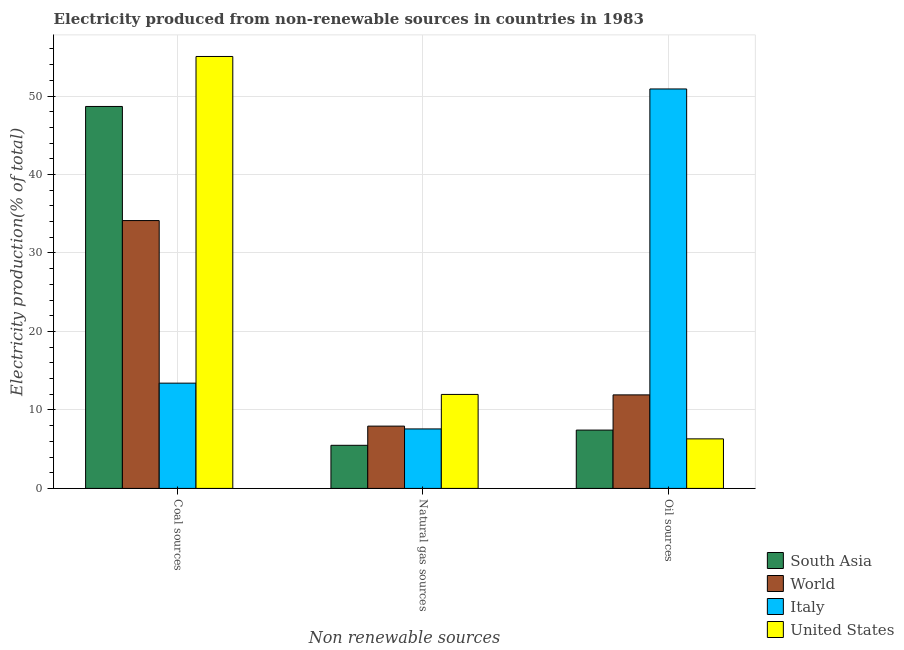How many groups of bars are there?
Offer a very short reply. 3. Are the number of bars per tick equal to the number of legend labels?
Your response must be concise. Yes. Are the number of bars on each tick of the X-axis equal?
Give a very brief answer. Yes. How many bars are there on the 2nd tick from the left?
Ensure brevity in your answer.  4. How many bars are there on the 3rd tick from the right?
Ensure brevity in your answer.  4. What is the label of the 1st group of bars from the left?
Ensure brevity in your answer.  Coal sources. What is the percentage of electricity produced by natural gas in Italy?
Keep it short and to the point. 7.58. Across all countries, what is the maximum percentage of electricity produced by oil sources?
Provide a short and direct response. 50.9. Across all countries, what is the minimum percentage of electricity produced by coal?
Keep it short and to the point. 13.41. In which country was the percentage of electricity produced by coal minimum?
Ensure brevity in your answer.  Italy. What is the total percentage of electricity produced by coal in the graph?
Your answer should be very brief. 151.25. What is the difference between the percentage of electricity produced by oil sources in Italy and that in World?
Make the answer very short. 38.98. What is the difference between the percentage of electricity produced by natural gas in Italy and the percentage of electricity produced by coal in United States?
Ensure brevity in your answer.  -47.46. What is the average percentage of electricity produced by coal per country?
Your answer should be very brief. 37.81. What is the difference between the percentage of electricity produced by natural gas and percentage of electricity produced by oil sources in Italy?
Your answer should be compact. -43.32. What is the ratio of the percentage of electricity produced by coal in United States to that in Italy?
Your answer should be compact. 4.1. Is the difference between the percentage of electricity produced by coal in South Asia and United States greater than the difference between the percentage of electricity produced by oil sources in South Asia and United States?
Your answer should be compact. No. What is the difference between the highest and the second highest percentage of electricity produced by coal?
Provide a short and direct response. 6.37. What is the difference between the highest and the lowest percentage of electricity produced by coal?
Provide a short and direct response. 41.63. Is the sum of the percentage of electricity produced by coal in South Asia and Italy greater than the maximum percentage of electricity produced by natural gas across all countries?
Offer a very short reply. Yes. What does the 2nd bar from the right in Oil sources represents?
Provide a short and direct response. Italy. Is it the case that in every country, the sum of the percentage of electricity produced by coal and percentage of electricity produced by natural gas is greater than the percentage of electricity produced by oil sources?
Offer a very short reply. No. How many countries are there in the graph?
Provide a short and direct response. 4. Does the graph contain grids?
Ensure brevity in your answer.  Yes. What is the title of the graph?
Offer a terse response. Electricity produced from non-renewable sources in countries in 1983. What is the label or title of the X-axis?
Your answer should be very brief. Non renewable sources. What is the label or title of the Y-axis?
Ensure brevity in your answer.  Electricity production(% of total). What is the Electricity production(% of total) in South Asia in Coal sources?
Make the answer very short. 48.67. What is the Electricity production(% of total) in World in Coal sources?
Your answer should be very brief. 34.13. What is the Electricity production(% of total) of Italy in Coal sources?
Make the answer very short. 13.41. What is the Electricity production(% of total) in United States in Coal sources?
Ensure brevity in your answer.  55.04. What is the Electricity production(% of total) in South Asia in Natural gas sources?
Ensure brevity in your answer.  5.49. What is the Electricity production(% of total) in World in Natural gas sources?
Provide a succinct answer. 7.94. What is the Electricity production(% of total) in Italy in Natural gas sources?
Make the answer very short. 7.58. What is the Electricity production(% of total) of United States in Natural gas sources?
Your response must be concise. 11.98. What is the Electricity production(% of total) of South Asia in Oil sources?
Offer a very short reply. 7.43. What is the Electricity production(% of total) in World in Oil sources?
Ensure brevity in your answer.  11.92. What is the Electricity production(% of total) in Italy in Oil sources?
Offer a terse response. 50.9. What is the Electricity production(% of total) of United States in Oil sources?
Ensure brevity in your answer.  6.31. Across all Non renewable sources, what is the maximum Electricity production(% of total) of South Asia?
Offer a terse response. 48.67. Across all Non renewable sources, what is the maximum Electricity production(% of total) of World?
Ensure brevity in your answer.  34.13. Across all Non renewable sources, what is the maximum Electricity production(% of total) in Italy?
Your answer should be very brief. 50.9. Across all Non renewable sources, what is the maximum Electricity production(% of total) of United States?
Ensure brevity in your answer.  55.04. Across all Non renewable sources, what is the minimum Electricity production(% of total) of South Asia?
Offer a very short reply. 5.49. Across all Non renewable sources, what is the minimum Electricity production(% of total) in World?
Make the answer very short. 7.94. Across all Non renewable sources, what is the minimum Electricity production(% of total) of Italy?
Your answer should be very brief. 7.58. Across all Non renewable sources, what is the minimum Electricity production(% of total) of United States?
Your response must be concise. 6.31. What is the total Electricity production(% of total) of South Asia in the graph?
Provide a succinct answer. 61.6. What is the total Electricity production(% of total) in World in the graph?
Your answer should be compact. 53.99. What is the total Electricity production(% of total) of Italy in the graph?
Make the answer very short. 71.89. What is the total Electricity production(% of total) of United States in the graph?
Provide a succinct answer. 73.33. What is the difference between the Electricity production(% of total) of South Asia in Coal sources and that in Natural gas sources?
Your response must be concise. 43.18. What is the difference between the Electricity production(% of total) of World in Coal sources and that in Natural gas sources?
Offer a very short reply. 26.19. What is the difference between the Electricity production(% of total) in Italy in Coal sources and that in Natural gas sources?
Provide a short and direct response. 5.83. What is the difference between the Electricity production(% of total) of United States in Coal sources and that in Natural gas sources?
Ensure brevity in your answer.  43.07. What is the difference between the Electricity production(% of total) in South Asia in Coal sources and that in Oil sources?
Keep it short and to the point. 41.24. What is the difference between the Electricity production(% of total) in World in Coal sources and that in Oil sources?
Offer a very short reply. 22.21. What is the difference between the Electricity production(% of total) in Italy in Coal sources and that in Oil sources?
Provide a succinct answer. -37.49. What is the difference between the Electricity production(% of total) of United States in Coal sources and that in Oil sources?
Offer a terse response. 48.73. What is the difference between the Electricity production(% of total) of South Asia in Natural gas sources and that in Oil sources?
Ensure brevity in your answer.  -1.94. What is the difference between the Electricity production(% of total) of World in Natural gas sources and that in Oil sources?
Provide a succinct answer. -3.98. What is the difference between the Electricity production(% of total) in Italy in Natural gas sources and that in Oil sources?
Give a very brief answer. -43.32. What is the difference between the Electricity production(% of total) of United States in Natural gas sources and that in Oil sources?
Give a very brief answer. 5.66. What is the difference between the Electricity production(% of total) in South Asia in Coal sources and the Electricity production(% of total) in World in Natural gas sources?
Your response must be concise. 40.73. What is the difference between the Electricity production(% of total) of South Asia in Coal sources and the Electricity production(% of total) of Italy in Natural gas sources?
Your answer should be compact. 41.09. What is the difference between the Electricity production(% of total) in South Asia in Coal sources and the Electricity production(% of total) in United States in Natural gas sources?
Your answer should be very brief. 36.7. What is the difference between the Electricity production(% of total) of World in Coal sources and the Electricity production(% of total) of Italy in Natural gas sources?
Your response must be concise. 26.55. What is the difference between the Electricity production(% of total) of World in Coal sources and the Electricity production(% of total) of United States in Natural gas sources?
Give a very brief answer. 22.16. What is the difference between the Electricity production(% of total) in Italy in Coal sources and the Electricity production(% of total) in United States in Natural gas sources?
Your answer should be compact. 1.44. What is the difference between the Electricity production(% of total) in South Asia in Coal sources and the Electricity production(% of total) in World in Oil sources?
Keep it short and to the point. 36.75. What is the difference between the Electricity production(% of total) in South Asia in Coal sources and the Electricity production(% of total) in Italy in Oil sources?
Make the answer very short. -2.23. What is the difference between the Electricity production(% of total) in South Asia in Coal sources and the Electricity production(% of total) in United States in Oil sources?
Offer a terse response. 42.36. What is the difference between the Electricity production(% of total) of World in Coal sources and the Electricity production(% of total) of Italy in Oil sources?
Your response must be concise. -16.77. What is the difference between the Electricity production(% of total) in World in Coal sources and the Electricity production(% of total) in United States in Oil sources?
Ensure brevity in your answer.  27.82. What is the difference between the Electricity production(% of total) in Italy in Coal sources and the Electricity production(% of total) in United States in Oil sources?
Offer a terse response. 7.1. What is the difference between the Electricity production(% of total) of South Asia in Natural gas sources and the Electricity production(% of total) of World in Oil sources?
Keep it short and to the point. -6.42. What is the difference between the Electricity production(% of total) of South Asia in Natural gas sources and the Electricity production(% of total) of Italy in Oil sources?
Your response must be concise. -45.41. What is the difference between the Electricity production(% of total) of South Asia in Natural gas sources and the Electricity production(% of total) of United States in Oil sources?
Your answer should be compact. -0.82. What is the difference between the Electricity production(% of total) of World in Natural gas sources and the Electricity production(% of total) of Italy in Oil sources?
Ensure brevity in your answer.  -42.96. What is the difference between the Electricity production(% of total) of World in Natural gas sources and the Electricity production(% of total) of United States in Oil sources?
Your answer should be very brief. 1.63. What is the difference between the Electricity production(% of total) in Italy in Natural gas sources and the Electricity production(% of total) in United States in Oil sources?
Your answer should be compact. 1.27. What is the average Electricity production(% of total) in South Asia per Non renewable sources?
Ensure brevity in your answer.  20.53. What is the average Electricity production(% of total) of World per Non renewable sources?
Provide a short and direct response. 18. What is the average Electricity production(% of total) of Italy per Non renewable sources?
Provide a short and direct response. 23.96. What is the average Electricity production(% of total) of United States per Non renewable sources?
Provide a short and direct response. 24.44. What is the difference between the Electricity production(% of total) in South Asia and Electricity production(% of total) in World in Coal sources?
Your response must be concise. 14.54. What is the difference between the Electricity production(% of total) of South Asia and Electricity production(% of total) of Italy in Coal sources?
Ensure brevity in your answer.  35.26. What is the difference between the Electricity production(% of total) in South Asia and Electricity production(% of total) in United States in Coal sources?
Ensure brevity in your answer.  -6.37. What is the difference between the Electricity production(% of total) of World and Electricity production(% of total) of Italy in Coal sources?
Make the answer very short. 20.72. What is the difference between the Electricity production(% of total) in World and Electricity production(% of total) in United States in Coal sources?
Offer a terse response. -20.91. What is the difference between the Electricity production(% of total) in Italy and Electricity production(% of total) in United States in Coal sources?
Give a very brief answer. -41.63. What is the difference between the Electricity production(% of total) of South Asia and Electricity production(% of total) of World in Natural gas sources?
Keep it short and to the point. -2.44. What is the difference between the Electricity production(% of total) of South Asia and Electricity production(% of total) of Italy in Natural gas sources?
Provide a short and direct response. -2.09. What is the difference between the Electricity production(% of total) of South Asia and Electricity production(% of total) of United States in Natural gas sources?
Make the answer very short. -6.48. What is the difference between the Electricity production(% of total) in World and Electricity production(% of total) in Italy in Natural gas sources?
Give a very brief answer. 0.36. What is the difference between the Electricity production(% of total) of World and Electricity production(% of total) of United States in Natural gas sources?
Offer a terse response. -4.04. What is the difference between the Electricity production(% of total) of Italy and Electricity production(% of total) of United States in Natural gas sources?
Offer a terse response. -4.39. What is the difference between the Electricity production(% of total) of South Asia and Electricity production(% of total) of World in Oil sources?
Your response must be concise. -4.48. What is the difference between the Electricity production(% of total) of South Asia and Electricity production(% of total) of Italy in Oil sources?
Make the answer very short. -43.47. What is the difference between the Electricity production(% of total) in South Asia and Electricity production(% of total) in United States in Oil sources?
Your answer should be compact. 1.12. What is the difference between the Electricity production(% of total) of World and Electricity production(% of total) of Italy in Oil sources?
Provide a short and direct response. -38.98. What is the difference between the Electricity production(% of total) in World and Electricity production(% of total) in United States in Oil sources?
Provide a short and direct response. 5.61. What is the difference between the Electricity production(% of total) in Italy and Electricity production(% of total) in United States in Oil sources?
Offer a very short reply. 44.59. What is the ratio of the Electricity production(% of total) in South Asia in Coal sources to that in Natural gas sources?
Make the answer very short. 8.86. What is the ratio of the Electricity production(% of total) in World in Coal sources to that in Natural gas sources?
Make the answer very short. 4.3. What is the ratio of the Electricity production(% of total) of Italy in Coal sources to that in Natural gas sources?
Keep it short and to the point. 1.77. What is the ratio of the Electricity production(% of total) in United States in Coal sources to that in Natural gas sources?
Make the answer very short. 4.6. What is the ratio of the Electricity production(% of total) of South Asia in Coal sources to that in Oil sources?
Your answer should be very brief. 6.55. What is the ratio of the Electricity production(% of total) of World in Coal sources to that in Oil sources?
Give a very brief answer. 2.86. What is the ratio of the Electricity production(% of total) of Italy in Coal sources to that in Oil sources?
Provide a short and direct response. 0.26. What is the ratio of the Electricity production(% of total) of United States in Coal sources to that in Oil sources?
Your response must be concise. 8.72. What is the ratio of the Electricity production(% of total) in South Asia in Natural gas sources to that in Oil sources?
Give a very brief answer. 0.74. What is the ratio of the Electricity production(% of total) of World in Natural gas sources to that in Oil sources?
Provide a short and direct response. 0.67. What is the ratio of the Electricity production(% of total) in Italy in Natural gas sources to that in Oil sources?
Provide a short and direct response. 0.15. What is the ratio of the Electricity production(% of total) of United States in Natural gas sources to that in Oil sources?
Offer a very short reply. 1.9. What is the difference between the highest and the second highest Electricity production(% of total) of South Asia?
Your answer should be very brief. 41.24. What is the difference between the highest and the second highest Electricity production(% of total) of World?
Your answer should be very brief. 22.21. What is the difference between the highest and the second highest Electricity production(% of total) in Italy?
Your answer should be compact. 37.49. What is the difference between the highest and the second highest Electricity production(% of total) in United States?
Ensure brevity in your answer.  43.07. What is the difference between the highest and the lowest Electricity production(% of total) of South Asia?
Offer a terse response. 43.18. What is the difference between the highest and the lowest Electricity production(% of total) in World?
Your response must be concise. 26.19. What is the difference between the highest and the lowest Electricity production(% of total) in Italy?
Provide a short and direct response. 43.32. What is the difference between the highest and the lowest Electricity production(% of total) of United States?
Make the answer very short. 48.73. 